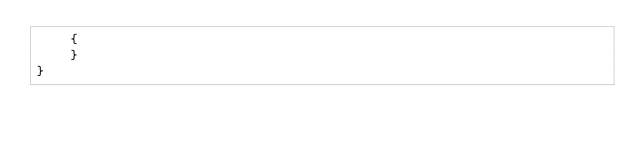<code> <loc_0><loc_0><loc_500><loc_500><_Java_>    {
    }
}
</code> 